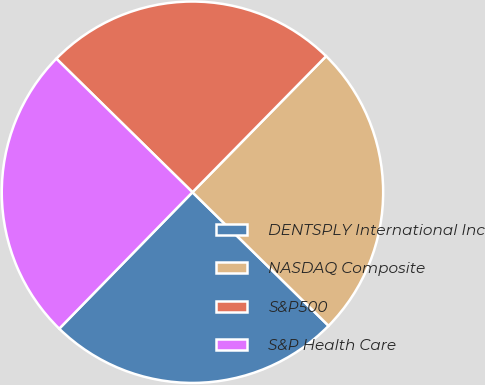Convert chart. <chart><loc_0><loc_0><loc_500><loc_500><pie_chart><fcel>DENTSPLY International Inc<fcel>NASDAQ Composite<fcel>S&P500<fcel>S&P Health Care<nl><fcel>24.96%<fcel>24.99%<fcel>25.01%<fcel>25.04%<nl></chart> 